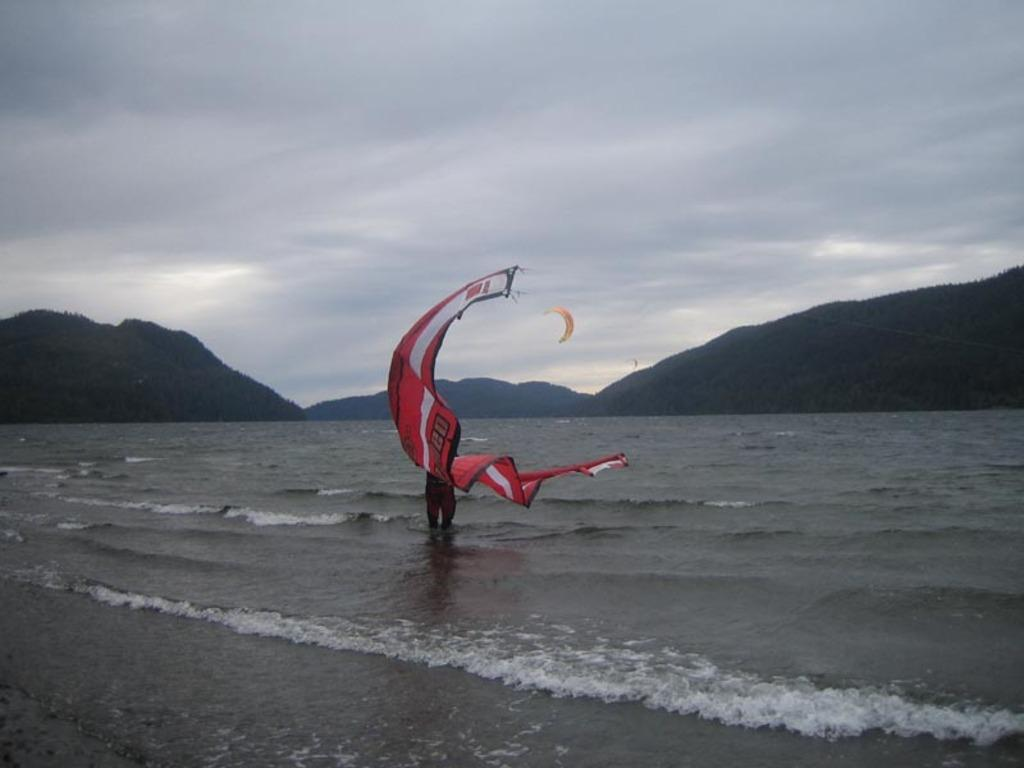Who or what is present in the image? There is a person in the image. What is the person holding? The person is holding a parachute. Where is the person located in the image? The person is standing in the water. What can be seen in the distance in the image? There are mountains visible in the background of the image. How many beds are visible in the image? There are no beds present in the image. 